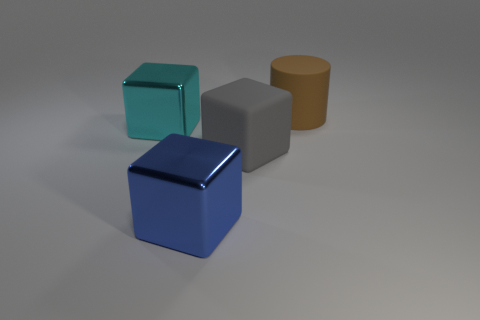Add 3 big brown rubber cylinders. How many objects exist? 7 Subtract all yellow cubes. Subtract all blue spheres. How many cubes are left? 3 Subtract all blocks. How many objects are left? 1 Subtract 0 green blocks. How many objects are left? 4 Subtract all large cylinders. Subtract all matte things. How many objects are left? 1 Add 1 gray matte objects. How many gray matte objects are left? 2 Add 1 large matte blocks. How many large matte blocks exist? 2 